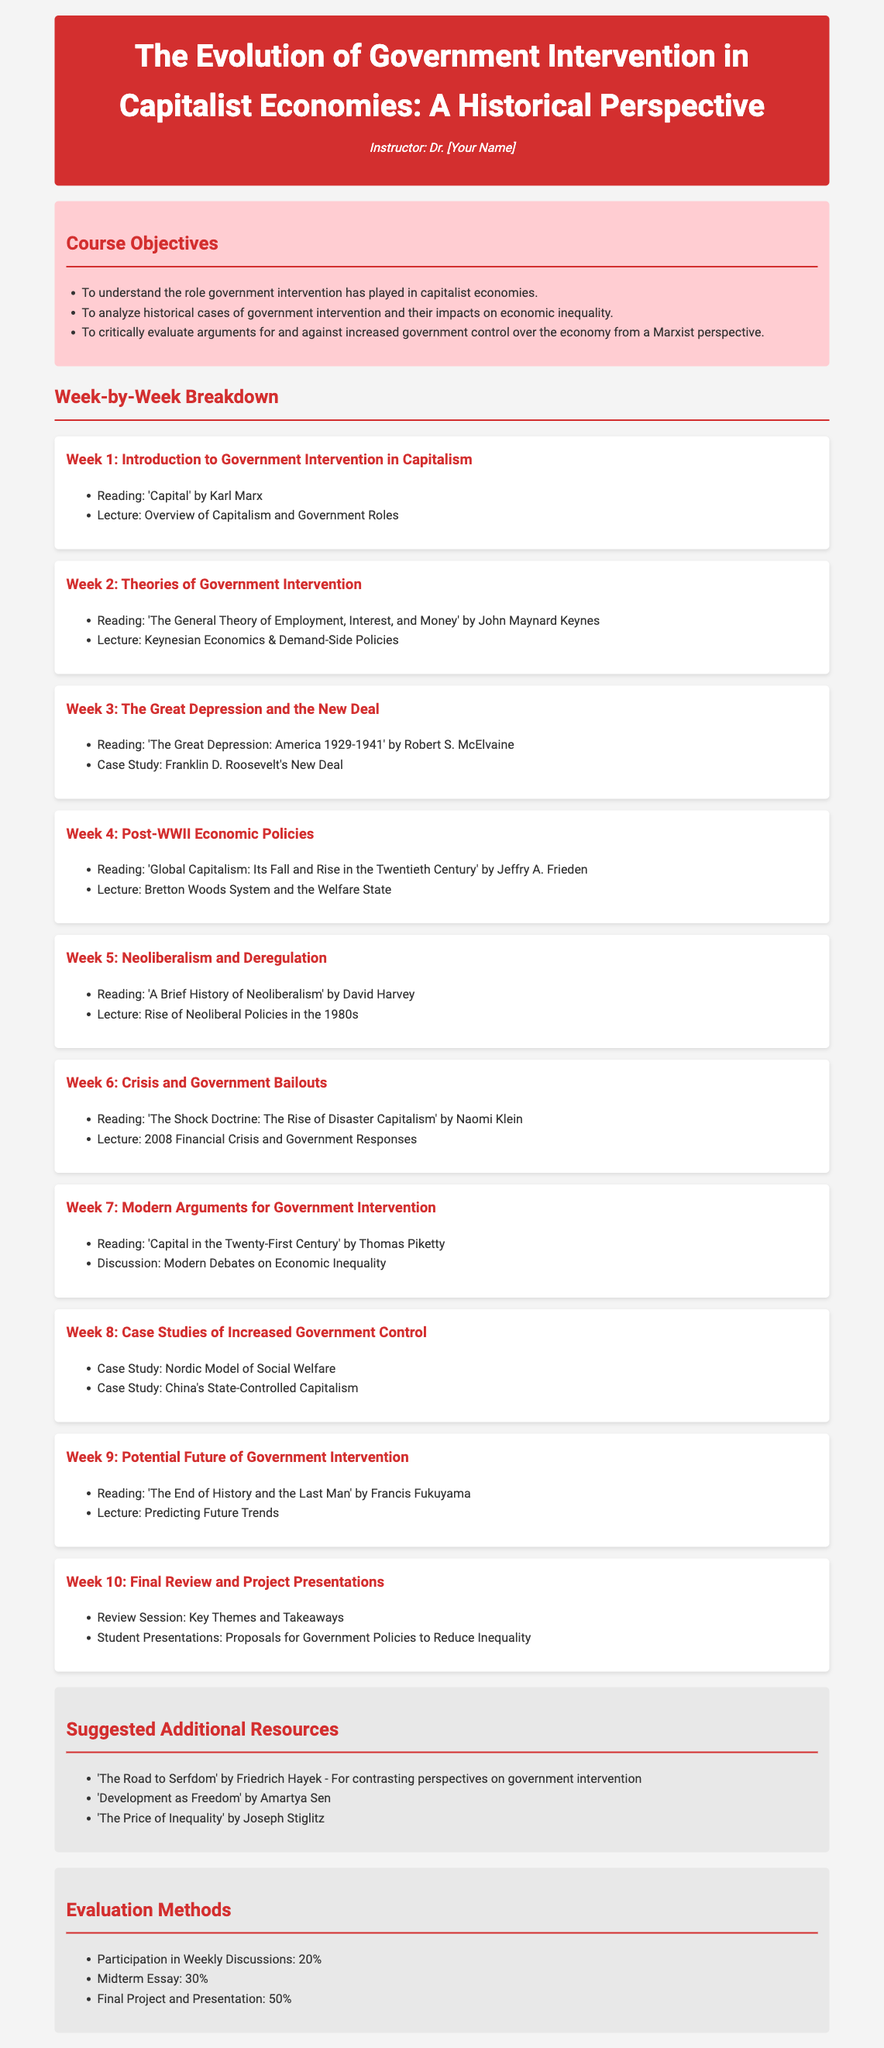What is the course title? The title is the main heading of the document, which describes the syllabus's focus.
Answer: The Evolution of Government Intervention in Capitalist Economies: A Historical Perspective Who is the instructor? The instructor's name is listed in the first section of the syllabus.
Answer: Dr. [Your Name] What is the percentage weight for the midterm essay? The midterm essay's weight is specified under the evaluation methods section.
Answer: 30% What book is assigned for Week 2? The reading material for Week 2 is mentioned in the weekly breakdown section.
Answer: The General Theory of Employment, Interest, and Money What case study is discussed in Week 8? The case study listed for Week 8 is provided in the respective week’s details.
Answer: Nordic Model of Social Welfare What is the theme for Week 10? The theme for Week 10 includes the final activities of the syllabus outlined in the last week section.
Answer: Final Review and Project Presentations How many weeks are covered in the syllabus? The number of weeks is counted by the sections presenting each week's topic.
Answer: 10 What type of reading is suggested for additional resources? The additional resources list includes types of readings related to contrasting perspectives.
Answer: Background readings What is the total percentage for class participation? Participation's percentage is stated under the evaluation methods section of the syllabus.
Answer: 20% 